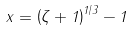Convert formula to latex. <formula><loc_0><loc_0><loc_500><loc_500>x = \left ( \zeta + 1 \right ) ^ { 1 / 3 } - 1</formula> 